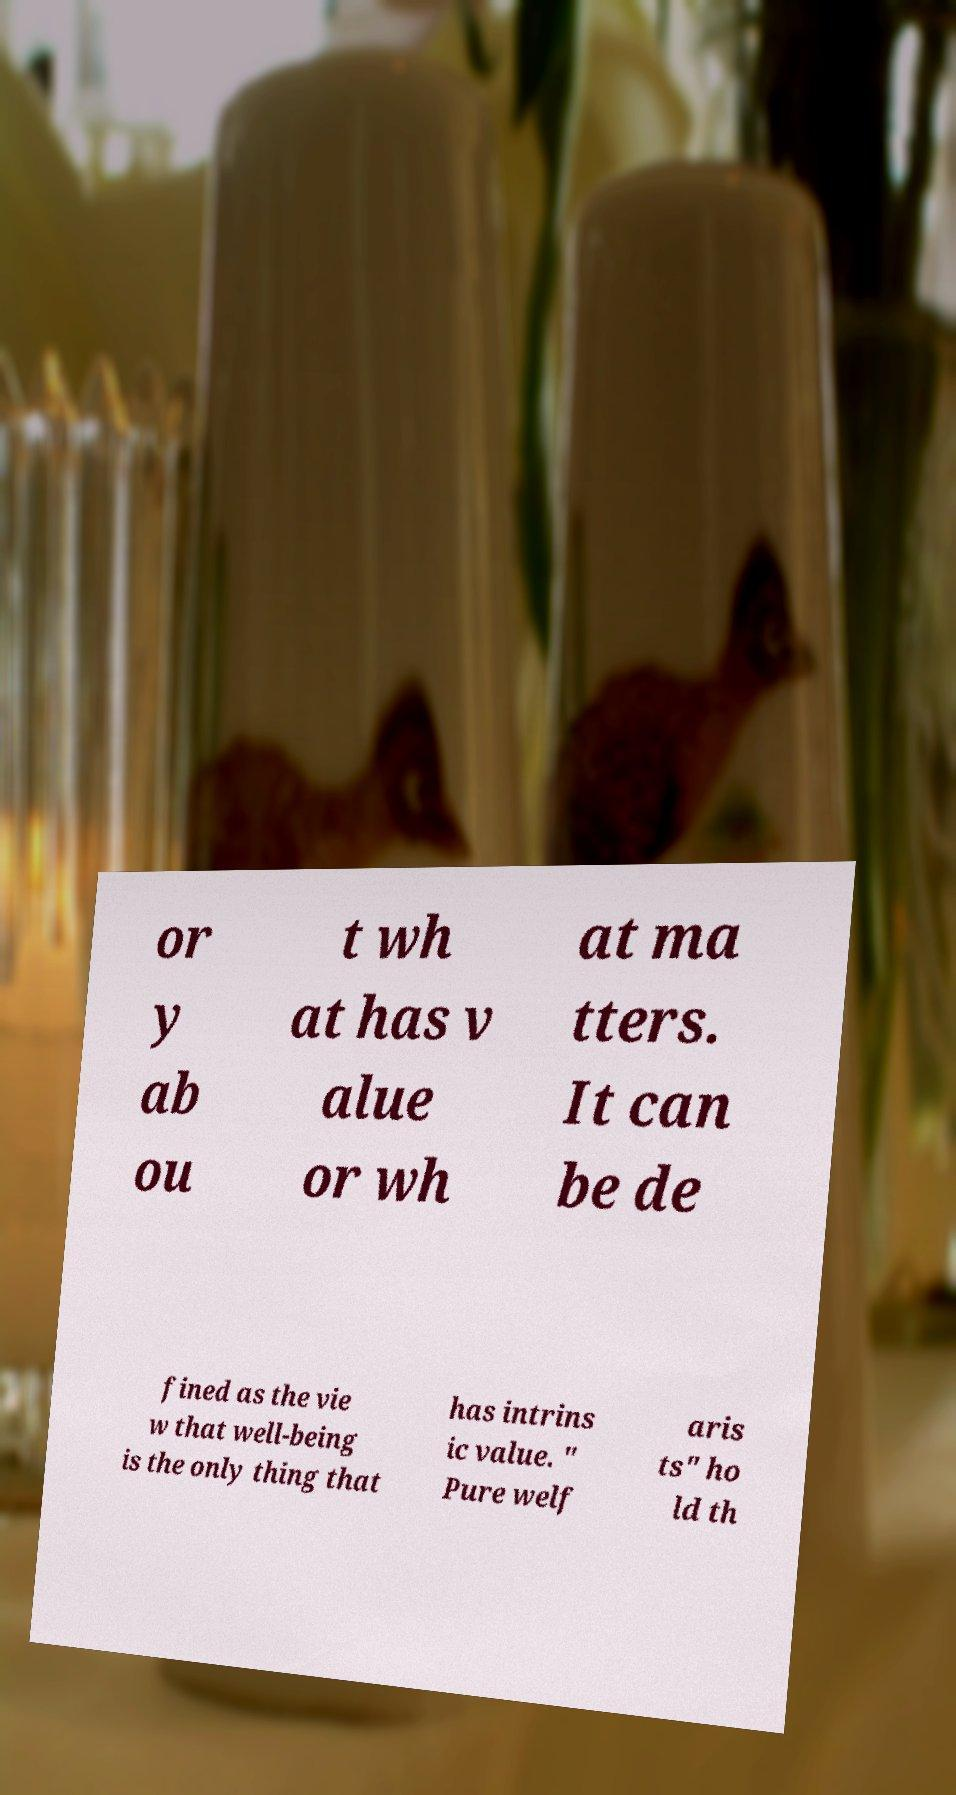Could you extract and type out the text from this image? or y ab ou t wh at has v alue or wh at ma tters. It can be de fined as the vie w that well-being is the only thing that has intrins ic value. " Pure welf aris ts" ho ld th 